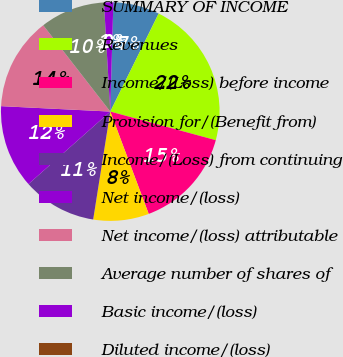<chart> <loc_0><loc_0><loc_500><loc_500><pie_chart><fcel>SUMMARY OF INCOME<fcel>Revenues<fcel>Income/(Loss) before income<fcel>Provision for/(Benefit from)<fcel>Income/(Loss) from continuing<fcel>Net income/(loss)<fcel>Net income/(loss) attributable<fcel>Average number of shares of<fcel>Basic income/(loss)<fcel>Diluted income/(loss)<nl><fcel>6.85%<fcel>21.92%<fcel>15.07%<fcel>8.22%<fcel>10.96%<fcel>12.33%<fcel>13.7%<fcel>9.59%<fcel>1.37%<fcel>0.0%<nl></chart> 